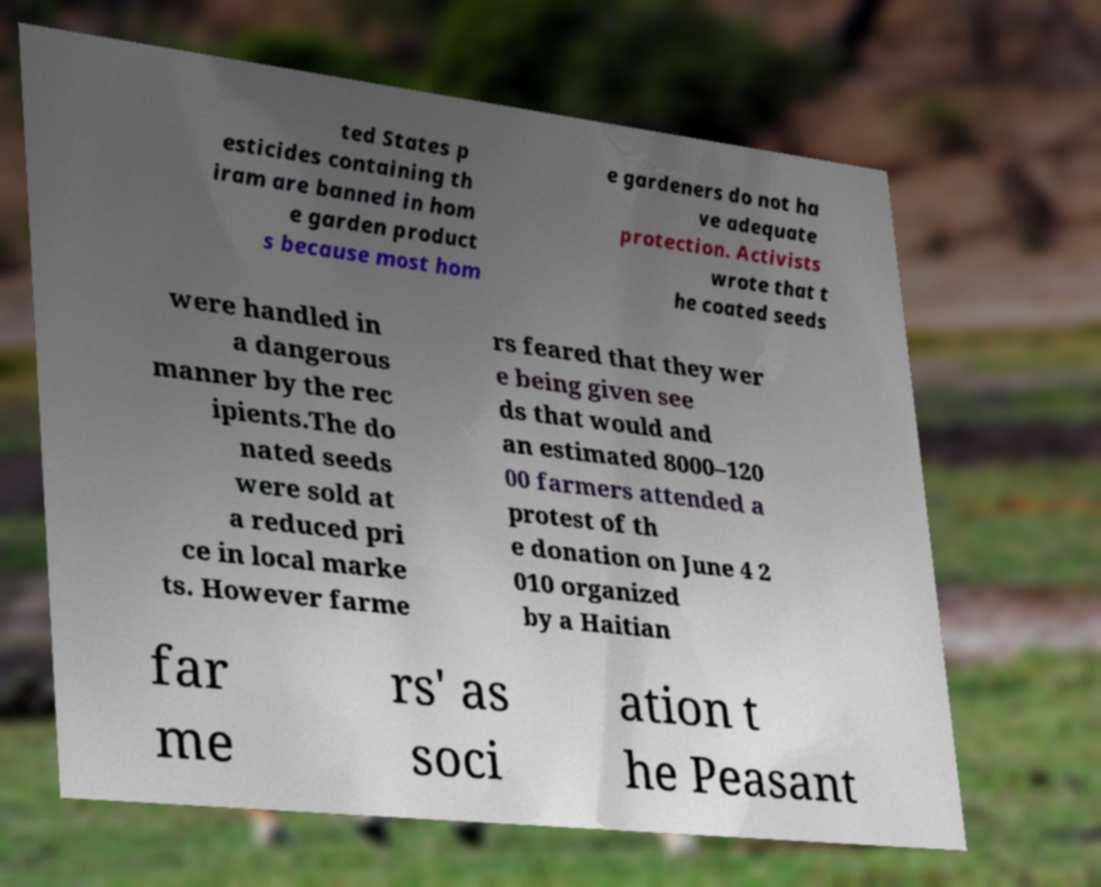Can you read and provide the text displayed in the image?This photo seems to have some interesting text. Can you extract and type it out for me? ted States p esticides containing th iram are banned in hom e garden product s because most hom e gardeners do not ha ve adequate protection. Activists wrote that t he coated seeds were handled in a dangerous manner by the rec ipients.The do nated seeds were sold at a reduced pri ce in local marke ts. However farme rs feared that they wer e being given see ds that would and an estimated 8000–120 00 farmers attended a protest of th e donation on June 4 2 010 organized by a Haitian far me rs' as soci ation t he Peasant 